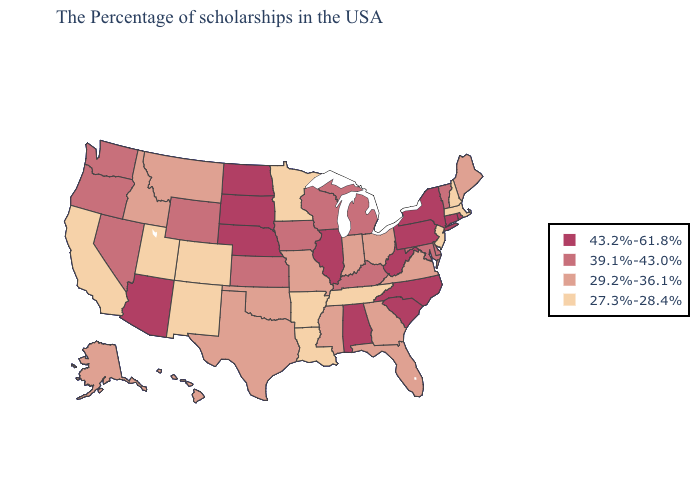Which states have the lowest value in the USA?
Answer briefly. Massachusetts, New Hampshire, New Jersey, Tennessee, Louisiana, Arkansas, Minnesota, Colorado, New Mexico, Utah, California. Name the states that have a value in the range 29.2%-36.1%?
Quick response, please. Maine, Virginia, Ohio, Florida, Georgia, Indiana, Mississippi, Missouri, Oklahoma, Texas, Montana, Idaho, Alaska, Hawaii. Does Montana have the same value as Hawaii?
Answer briefly. Yes. Does Wyoming have the highest value in the USA?
Be succinct. No. Does Connecticut have the highest value in the USA?
Be succinct. Yes. What is the highest value in the MidWest ?
Give a very brief answer. 43.2%-61.8%. Name the states that have a value in the range 43.2%-61.8%?
Concise answer only. Rhode Island, Connecticut, New York, Pennsylvania, North Carolina, South Carolina, West Virginia, Alabama, Illinois, Nebraska, South Dakota, North Dakota, Arizona. What is the value of Wyoming?
Give a very brief answer. 39.1%-43.0%. What is the value of Oregon?
Answer briefly. 39.1%-43.0%. What is the lowest value in the Northeast?
Concise answer only. 27.3%-28.4%. Does Tennessee have the highest value in the USA?
Keep it brief. No. Which states have the lowest value in the MidWest?
Keep it brief. Minnesota. What is the highest value in the USA?
Quick response, please. 43.2%-61.8%. Name the states that have a value in the range 39.1%-43.0%?
Be succinct. Vermont, Delaware, Maryland, Michigan, Kentucky, Wisconsin, Iowa, Kansas, Wyoming, Nevada, Washington, Oregon. What is the highest value in the USA?
Quick response, please. 43.2%-61.8%. 